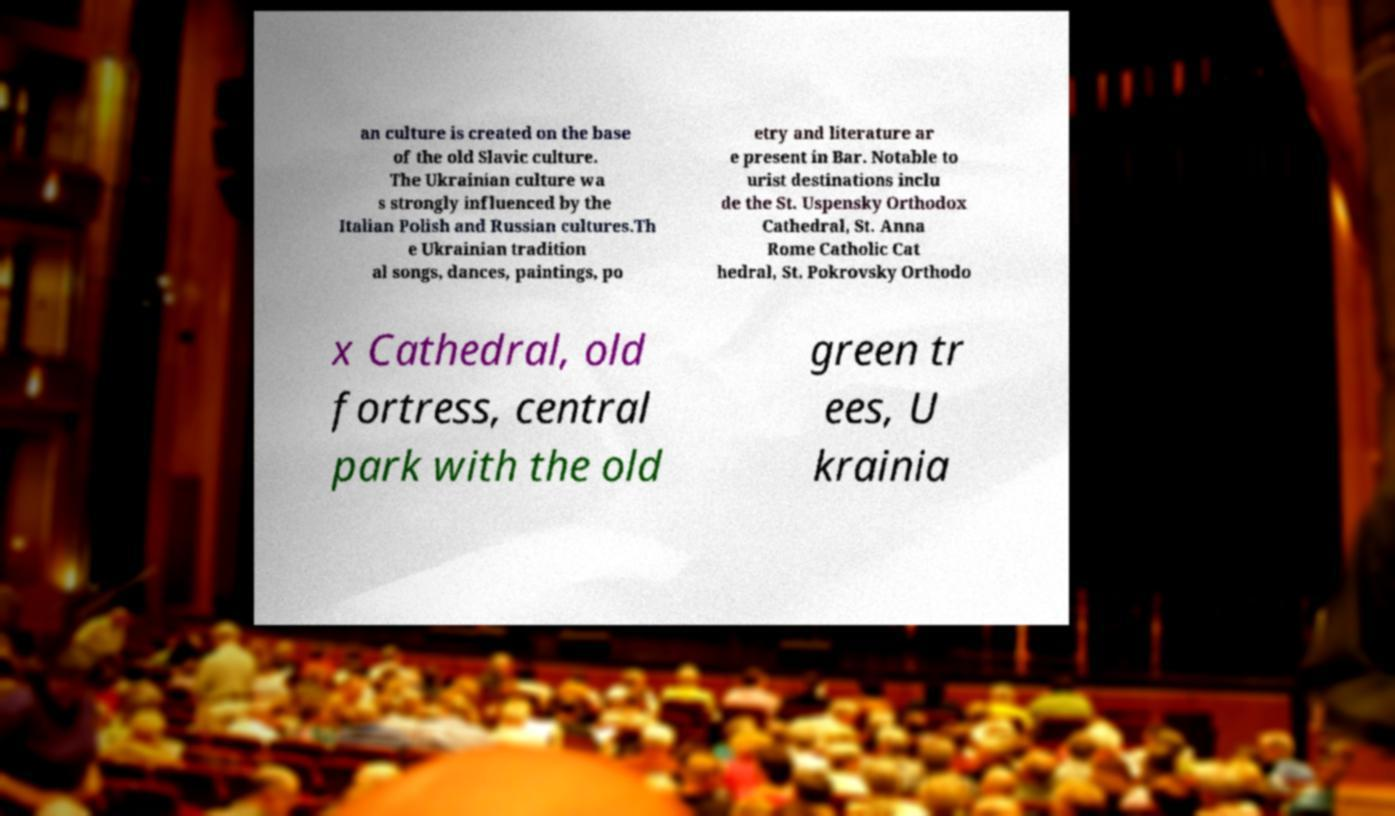Could you extract and type out the text from this image? an culture is created on the base of the old Slavic culture. The Ukrainian culture wa s strongly influenced by the Italian Polish and Russian cultures.Th e Ukrainian tradition al songs, dances, paintings, po etry and literature ar e present in Bar. Notable to urist destinations inclu de the St. Uspensky Orthodox Cathedral, St. Anna Rome Catholic Cat hedral, St. Pokrovsky Orthodo x Cathedral, old fortress, central park with the old green tr ees, U krainia 